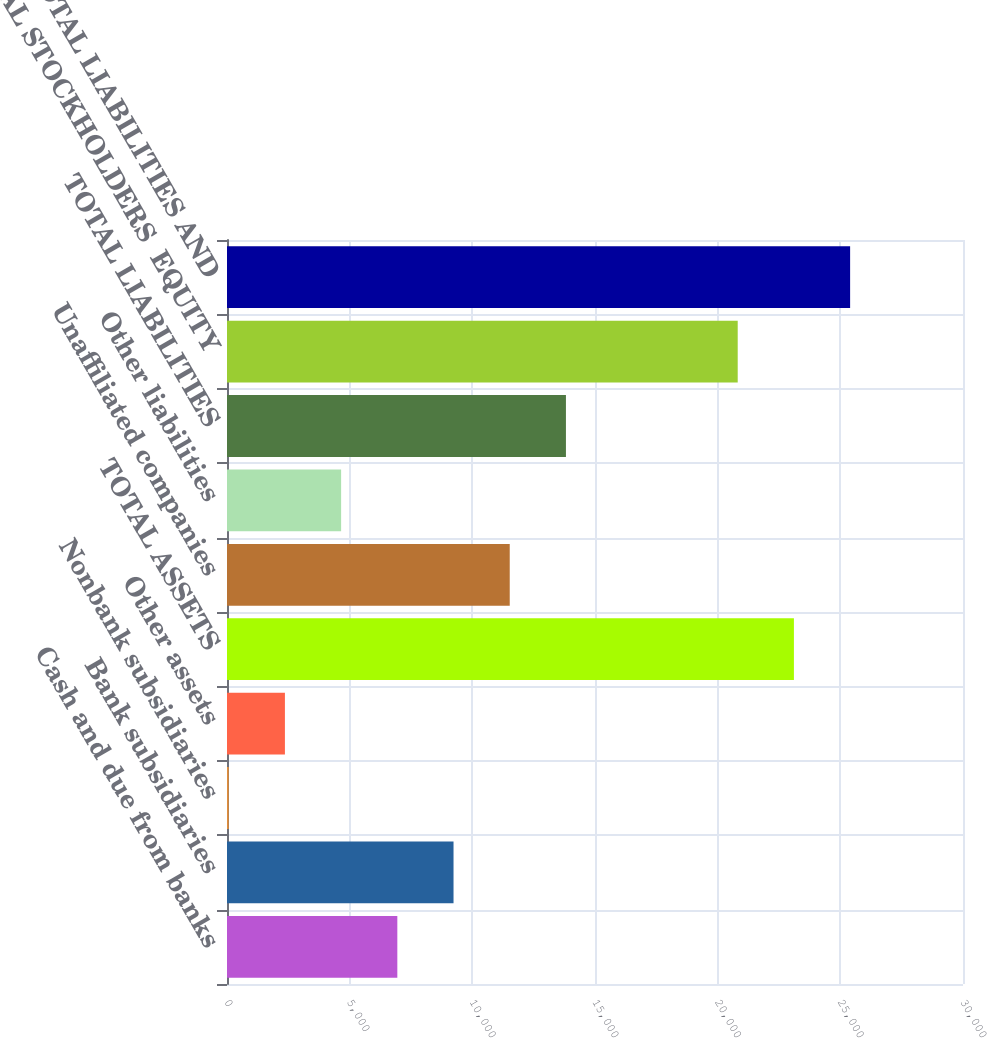Convert chart to OTSL. <chart><loc_0><loc_0><loc_500><loc_500><bar_chart><fcel>Cash and due from banks<fcel>Bank subsidiaries<fcel>Nonbank subsidiaries<fcel>Other assets<fcel>TOTAL ASSETS<fcel>Unaffiliated companies<fcel>Other liabilities<fcel>TOTAL LIABILITIES<fcel>TOTAL STOCKHOLDERS EQUITY<fcel>TOTAL LIABILITIES AND<nl><fcel>6942.7<fcel>9233.6<fcel>70<fcel>2360.9<fcel>23107.9<fcel>11524.5<fcel>4651.8<fcel>13815.4<fcel>20817<fcel>25398.8<nl></chart> 